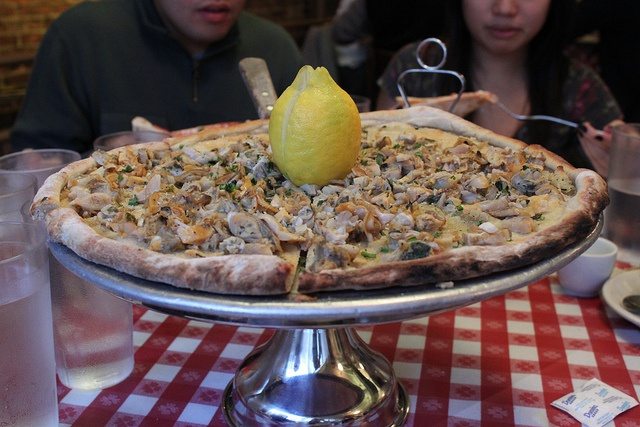Describe the objects in this image and their specific colors. I can see pizza in maroon, darkgray, tan, and gray tones, dining table in maroon, brown, darkgray, and purple tones, people in maroon, black, and gray tones, people in maroon, black, and brown tones, and cup in maroon and gray tones in this image. 